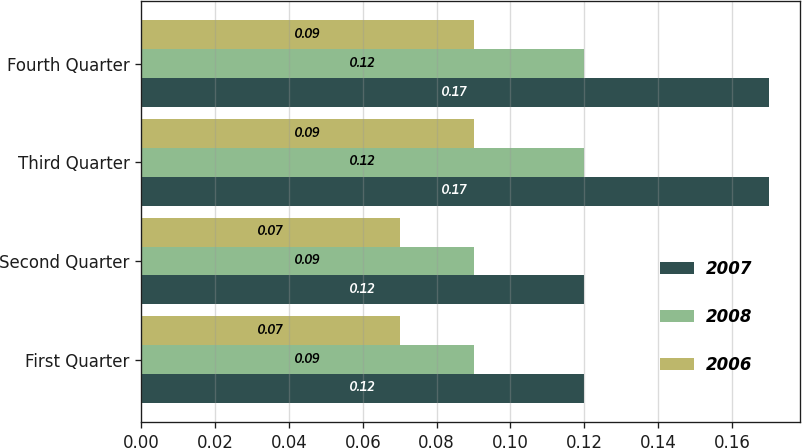<chart> <loc_0><loc_0><loc_500><loc_500><stacked_bar_chart><ecel><fcel>First Quarter<fcel>Second Quarter<fcel>Third Quarter<fcel>Fourth Quarter<nl><fcel>2007<fcel>0.12<fcel>0.12<fcel>0.17<fcel>0.17<nl><fcel>2008<fcel>0.09<fcel>0.09<fcel>0.12<fcel>0.12<nl><fcel>2006<fcel>0.07<fcel>0.07<fcel>0.09<fcel>0.09<nl></chart> 